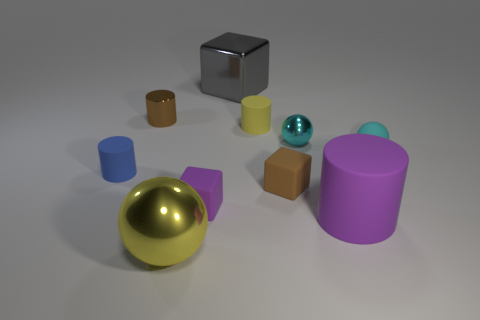What is the size of the cube that is the same color as the small metal cylinder?
Your response must be concise. Small. There is a small brown shiny thing to the left of the tiny rubber ball; what number of cylinders are in front of it?
Your answer should be very brief. 3. There is a object that is the same color as the matte ball; what is its material?
Provide a succinct answer. Metal. What number of other objects are the same color as the big cube?
Your answer should be compact. 0. What color is the ball that is on the right side of the tiny metallic thing that is on the right side of the tiny brown shiny cylinder?
Ensure brevity in your answer.  Cyan. Is there a big metal object that has the same color as the rubber sphere?
Ensure brevity in your answer.  No. How many metallic things are either cyan things or cylinders?
Give a very brief answer. 2. Are there any small brown objects made of the same material as the purple cube?
Your answer should be compact. Yes. What number of things are in front of the yellow cylinder and to the left of the large yellow metallic thing?
Make the answer very short. 1. Are there fewer balls behind the brown rubber cube than small brown cylinders that are in front of the yellow cylinder?
Your response must be concise. No. 